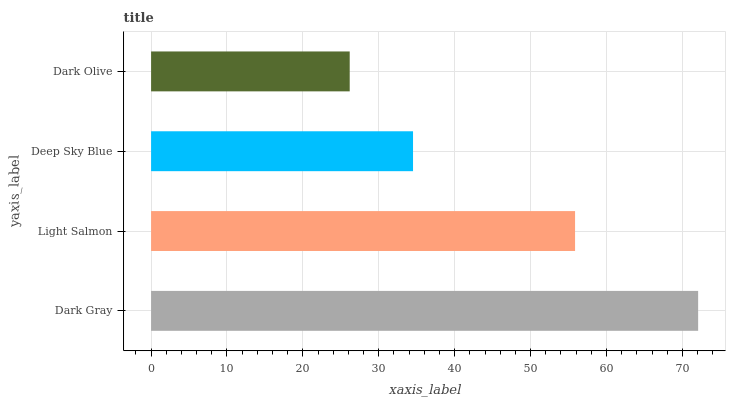Is Dark Olive the minimum?
Answer yes or no. Yes. Is Dark Gray the maximum?
Answer yes or no. Yes. Is Light Salmon the minimum?
Answer yes or no. No. Is Light Salmon the maximum?
Answer yes or no. No. Is Dark Gray greater than Light Salmon?
Answer yes or no. Yes. Is Light Salmon less than Dark Gray?
Answer yes or no. Yes. Is Light Salmon greater than Dark Gray?
Answer yes or no. No. Is Dark Gray less than Light Salmon?
Answer yes or no. No. Is Light Salmon the high median?
Answer yes or no. Yes. Is Deep Sky Blue the low median?
Answer yes or no. Yes. Is Dark Olive the high median?
Answer yes or no. No. Is Dark Olive the low median?
Answer yes or no. No. 